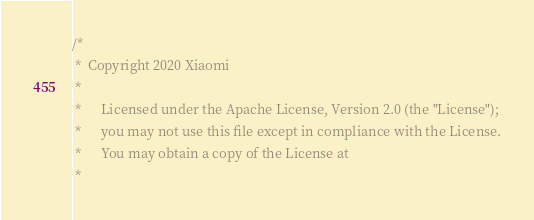Convert code to text. <code><loc_0><loc_0><loc_500><loc_500><_SQL_>/*
 *  Copyright 2020 Xiaomi
 *
 *      Licensed under the Apache License, Version 2.0 (the "License");
 *      you may not use this file except in compliance with the License.
 *      You may obtain a copy of the License at
 *</code> 